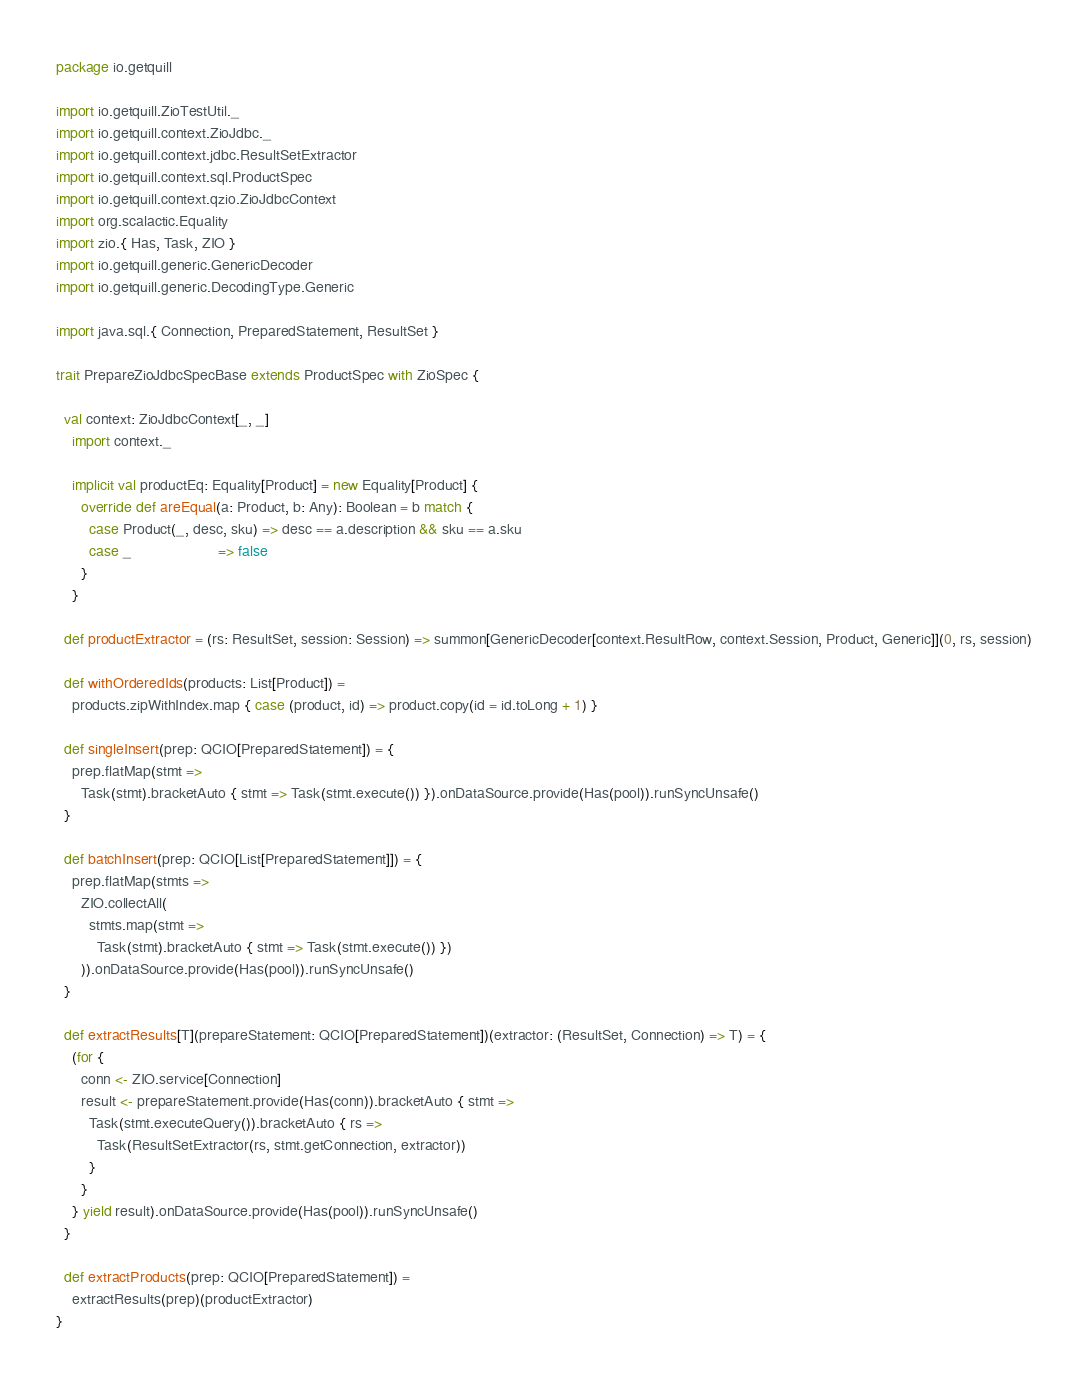Convert code to text. <code><loc_0><loc_0><loc_500><loc_500><_Scala_>package io.getquill

import io.getquill.ZioTestUtil._
import io.getquill.context.ZioJdbc._
import io.getquill.context.jdbc.ResultSetExtractor
import io.getquill.context.sql.ProductSpec
import io.getquill.context.qzio.ZioJdbcContext
import org.scalactic.Equality
import zio.{ Has, Task, ZIO }
import io.getquill.generic.GenericDecoder
import io.getquill.generic.DecodingType.Generic

import java.sql.{ Connection, PreparedStatement, ResultSet }

trait PrepareZioJdbcSpecBase extends ProductSpec with ZioSpec {

  val context: ZioJdbcContext[_, _]
    import context._

    implicit val productEq: Equality[Product] = new Equality[Product] {
      override def areEqual(a: Product, b: Any): Boolean = b match {
        case Product(_, desc, sku) => desc == a.description && sku == a.sku
        case _                     => false
      }
    }

  def productExtractor = (rs: ResultSet, session: Session) => summon[GenericDecoder[context.ResultRow, context.Session, Product, Generic]](0, rs, session)

  def withOrderedIds(products: List[Product]) =
    products.zipWithIndex.map { case (product, id) => product.copy(id = id.toLong + 1) }

  def singleInsert(prep: QCIO[PreparedStatement]) = {
    prep.flatMap(stmt =>
      Task(stmt).bracketAuto { stmt => Task(stmt.execute()) }).onDataSource.provide(Has(pool)).runSyncUnsafe()
  }

  def batchInsert(prep: QCIO[List[PreparedStatement]]) = {
    prep.flatMap(stmts =>
      ZIO.collectAll(
        stmts.map(stmt =>
          Task(stmt).bracketAuto { stmt => Task(stmt.execute()) })
      )).onDataSource.provide(Has(pool)).runSyncUnsafe()
  }

  def extractResults[T](prepareStatement: QCIO[PreparedStatement])(extractor: (ResultSet, Connection) => T) = {
    (for {
      conn <- ZIO.service[Connection]
      result <- prepareStatement.provide(Has(conn)).bracketAuto { stmt =>
        Task(stmt.executeQuery()).bracketAuto { rs =>
          Task(ResultSetExtractor(rs, stmt.getConnection, extractor))
        }
      }
    } yield result).onDataSource.provide(Has(pool)).runSyncUnsafe()
  }

  def extractProducts(prep: QCIO[PreparedStatement]) =
    extractResults(prep)(productExtractor)
}
</code> 